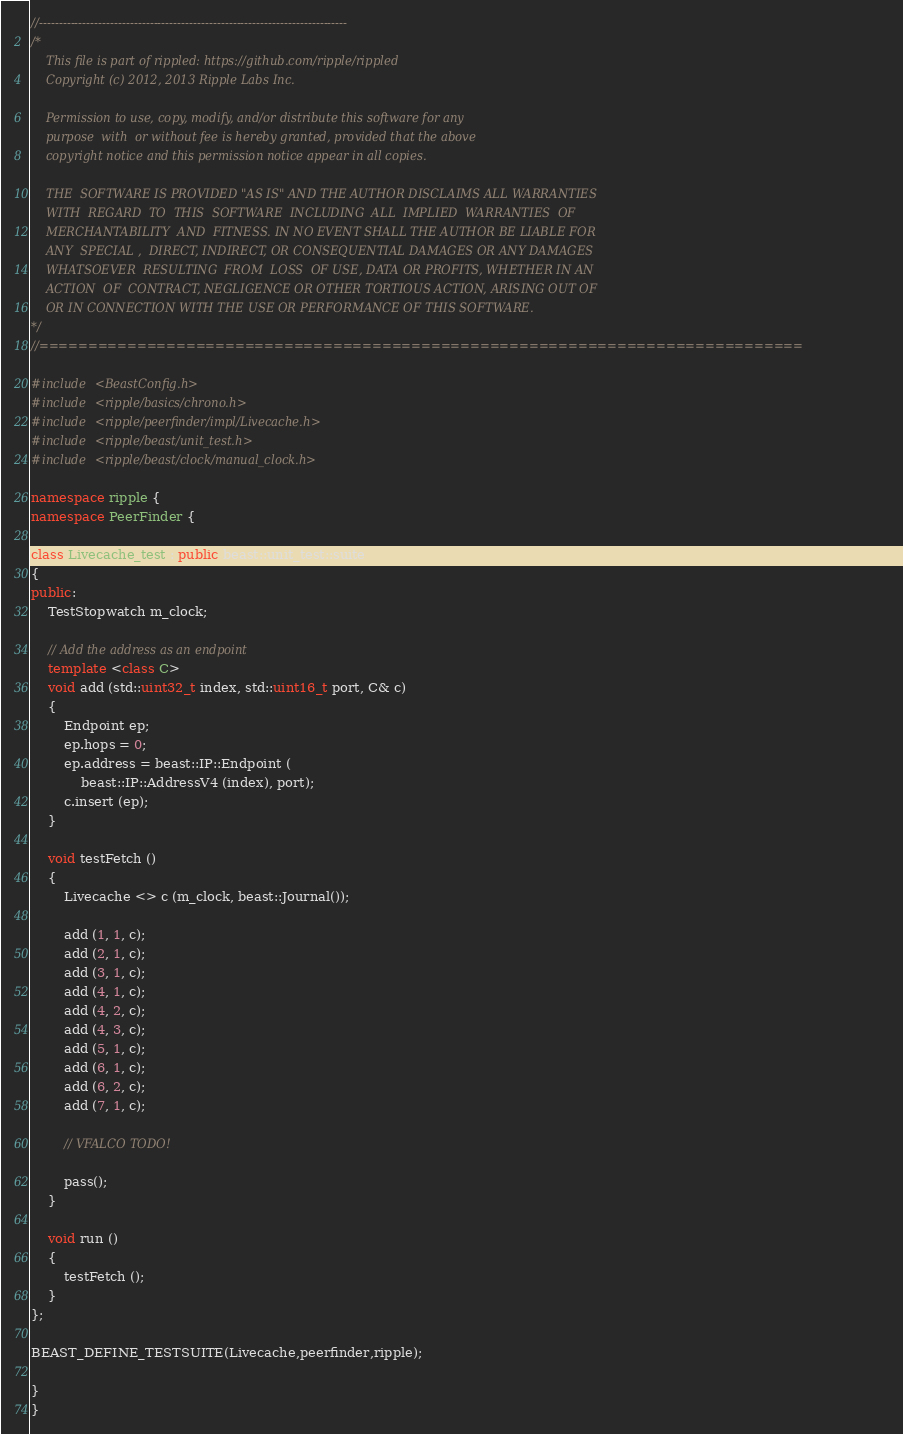<code> <loc_0><loc_0><loc_500><loc_500><_C++_>//------------------------------------------------------------------------------
/*
    This file is part of rippled: https://github.com/ripple/rippled
    Copyright (c) 2012, 2013 Ripple Labs Inc.

    Permission to use, copy, modify, and/or distribute this software for any
    purpose  with  or without fee is hereby granted, provided that the above
    copyright notice and this permission notice appear in all copies.

    THE  SOFTWARE IS PROVIDED "AS IS" AND THE AUTHOR DISCLAIMS ALL WARRANTIES
    WITH  REGARD  TO  THIS  SOFTWARE  INCLUDING  ALL  IMPLIED  WARRANTIES  OF
    MERCHANTABILITY  AND  FITNESS. IN NO EVENT SHALL THE AUTHOR BE LIABLE FOR
    ANY  SPECIAL ,  DIRECT, INDIRECT, OR CONSEQUENTIAL DAMAGES OR ANY DAMAGES
    WHATSOEVER  RESULTING  FROM  LOSS  OF USE, DATA OR PROFITS, WHETHER IN AN
    ACTION  OF  CONTRACT, NEGLIGENCE OR OTHER TORTIOUS ACTION, ARISING OUT OF
    OR IN CONNECTION WITH THE USE OR PERFORMANCE OF THIS SOFTWARE.
*/
//==============================================================================

#include <BeastConfig.h>
#include <ripple/basics/chrono.h>
#include <ripple/peerfinder/impl/Livecache.h>
#include <ripple/beast/unit_test.h>
#include <ripple/beast/clock/manual_clock.h>

namespace ripple {
namespace PeerFinder {

class Livecache_test : public beast::unit_test::suite
{
public:
    TestStopwatch m_clock;

    // Add the address as an endpoint
    template <class C>
    void add (std::uint32_t index, std::uint16_t port, C& c)
    {
        Endpoint ep;
        ep.hops = 0;
        ep.address = beast::IP::Endpoint (
            beast::IP::AddressV4 (index), port);
        c.insert (ep);
    }

    void testFetch ()
    {
        Livecache <> c (m_clock, beast::Journal());

        add (1, 1, c);
        add (2, 1, c);
        add (3, 1, c);
        add (4, 1, c);
        add (4, 2, c);
        add (4, 3, c);
        add (5, 1, c);
        add (6, 1, c);
        add (6, 2, c);
        add (7, 1, c);

        // VFALCO TODO!

        pass();
    }

    void run ()
    {
        testFetch ();
    }
};

BEAST_DEFINE_TESTSUITE(Livecache,peerfinder,ripple);

}
}
</code> 